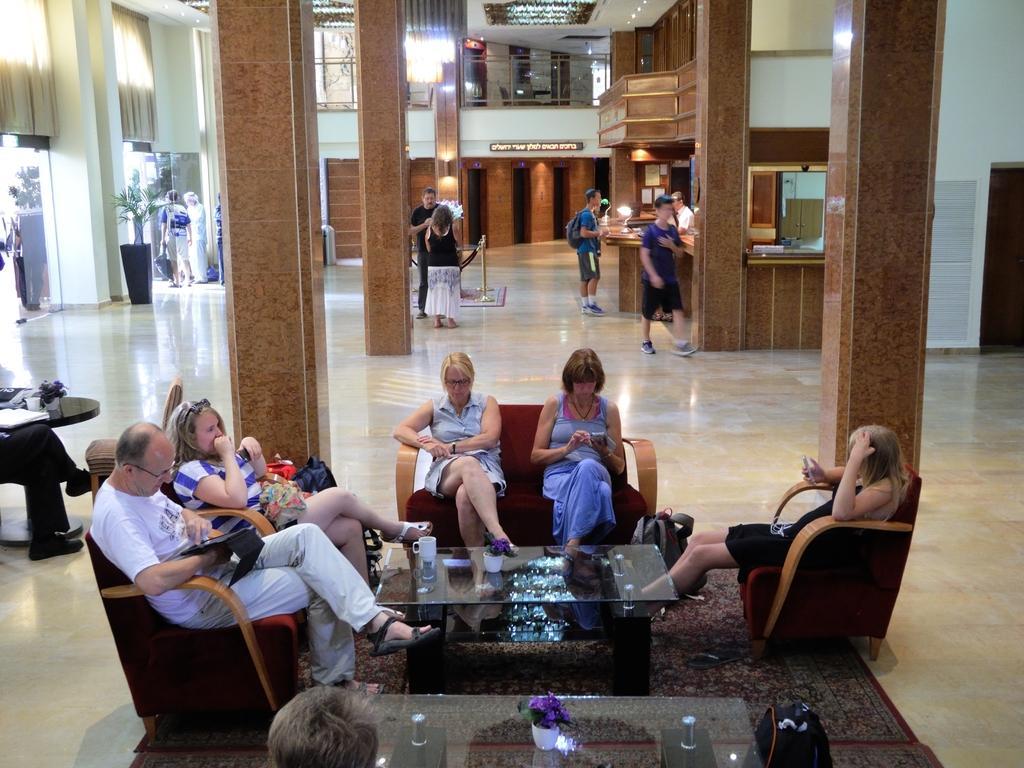Describe this image in one or two sentences. In this picture i could see some persons sitting on the sofa, it looks like a big hall, some in the back ground are walking and standing. There is flower pot in the left of the picture and there is centerpiece table in middle of these persons. There are some pillars in between the room. 